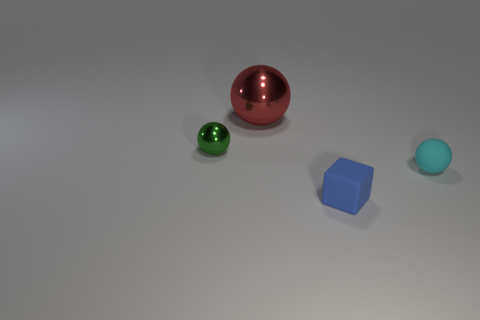Add 3 brown metal blocks. How many objects exist? 7 Subtract all balls. How many objects are left? 1 Subtract 0 brown cylinders. How many objects are left? 4 Subtract all tiny green rubber cylinders. Subtract all big objects. How many objects are left? 3 Add 1 green objects. How many green objects are left? 2 Add 1 purple cubes. How many purple cubes exist? 1 